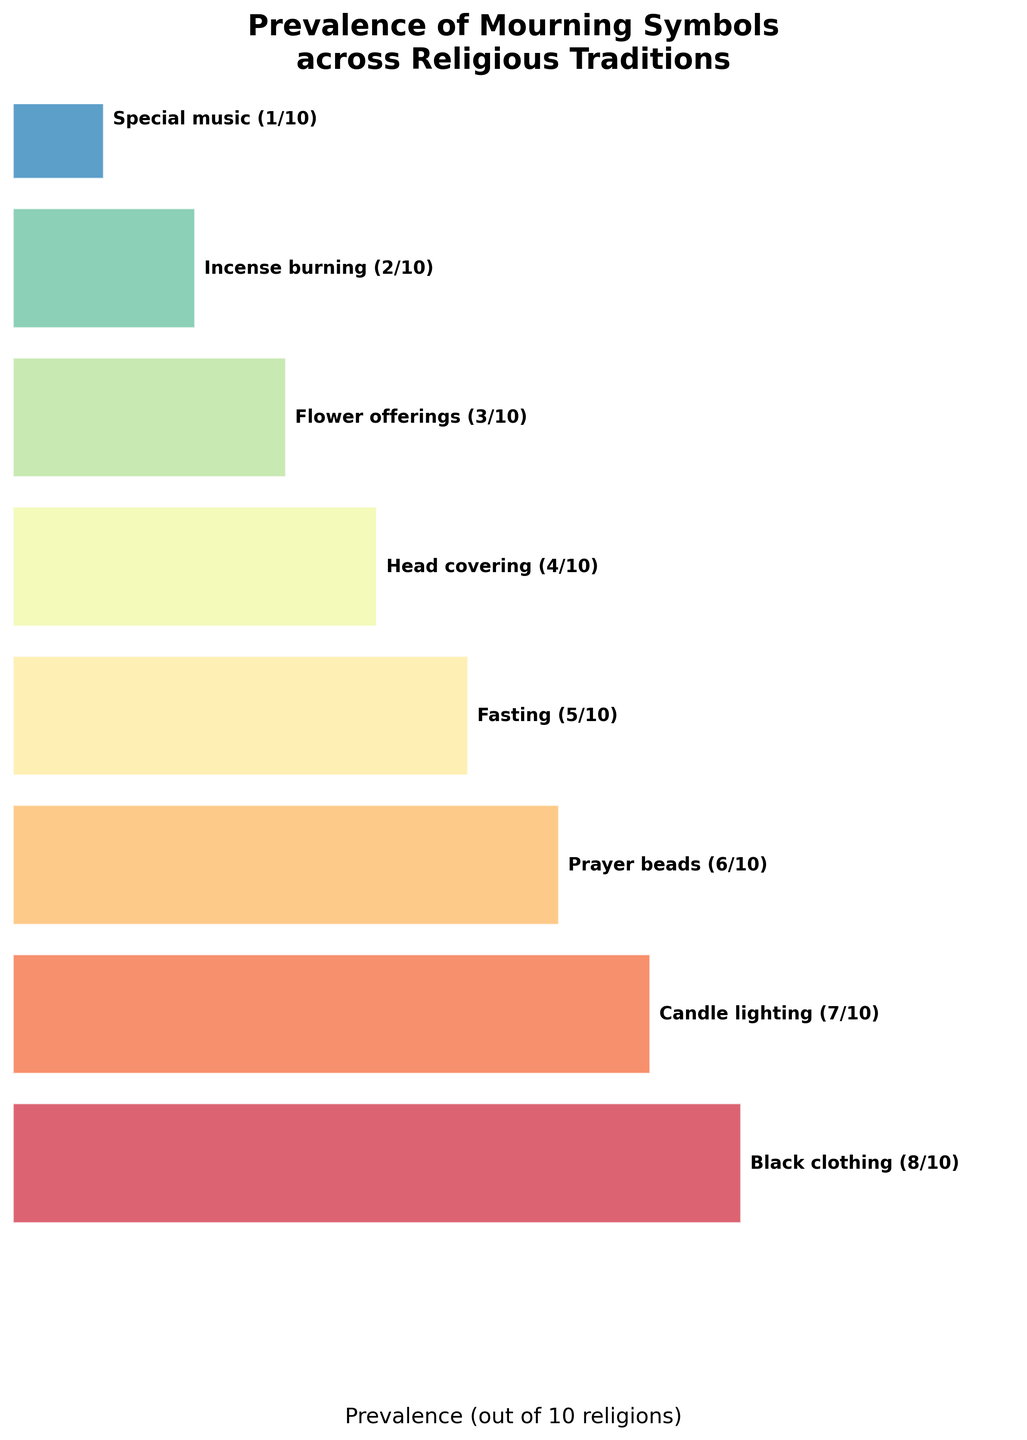what is the most prevalent mourning symbol? The most prevalent mourning symbol is identified by the highest prevalence value. According to the figure, "Black clothing" has the highest prevalence of 8 out of 10.
Answer: Black clothing What is the title of the figure? The title of the figure is usually displayed at the top of the chart. In this case, it's "Prevalence of Mourning Symbols across Religious Traditions".
Answer: Prevalence of Mourning Symbols across Religious Traditions How many mourning symbols are represented in the chart? The total number of mourning symbols can be counted from the y-axis or the labels on the polygons. According to the figure, there are 8 symbols.
Answer: 8 Which mourning symbol has the lowest prevalence? The mourning symbol with the lowest prevalence is identified by the smallest prevalence value. In the figure, "Special music" has the lowest prevalence of 1 out of 10.
Answer: Special music What is the range of prevalence values for the mourning symbols? The range is calculated by subtracting the lowest prevalence value from the highest prevalence value. The highest prevalence is 8 (Black clothing), and the lowest is 1 (Special music), so the range is 8 - 1.
Answer: 7 How many symbols have a prevalence greater than or equal to half of the total religions? Half of the total religions is 10/2 = 5. The symbols with prevalence 5 or greater are: "Black clothing" (8), "Candle lighting" (7), "Prayer beads" (6), and "Fasting" (5), totaling 4 symbols.
Answer: 4 Which symbols are less prevalent than "Prayer beads"? Checking the prevalence values, "Prayer beads" has a prevalence of 6. Symbols with lower prevalence are "Fasting" (5), "Head covering" (4), "Flower offerings" (3), "Incense burning" (2), and "Special music" (1).
Answer: Fasting, Head covering, Flower offerings, Incense burning, Special music What percentage of religions observe "Head covering" as a mourning symbol? The percentage is calculated by (Prevalence/Total Religions) * 100. For "Head covering," it is (4/10) * 100 = 40%.
Answer: 40% How does the prevalence of "Incense burning" compare to "Flower offerings"? According to the figure, "Incense burning" has a prevalence of 2, while "Flower offerings" has a prevalence of 3. "Flower offerings" is more prevalent by 1.
Answer: Flower offerings is more prevalent by 1 